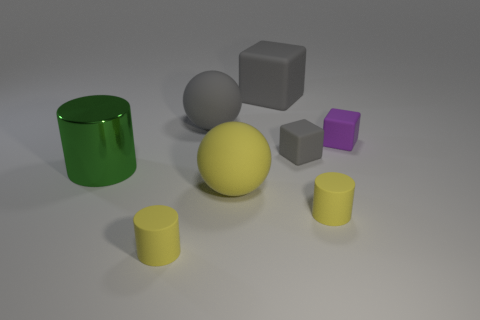Subtract all rubber cylinders. How many cylinders are left? 1 Add 1 big metallic cylinders. How many objects exist? 9 Subtract all yellow balls. How many balls are left? 1 Subtract all cylinders. How many objects are left? 5 Subtract 1 cubes. How many cubes are left? 2 Subtract all red blocks. How many yellow cylinders are left? 2 Subtract 0 brown cylinders. How many objects are left? 8 Subtract all gray cubes. Subtract all purple balls. How many cubes are left? 1 Subtract all big matte objects. Subtract all tiny purple things. How many objects are left? 4 Add 3 large cylinders. How many large cylinders are left? 4 